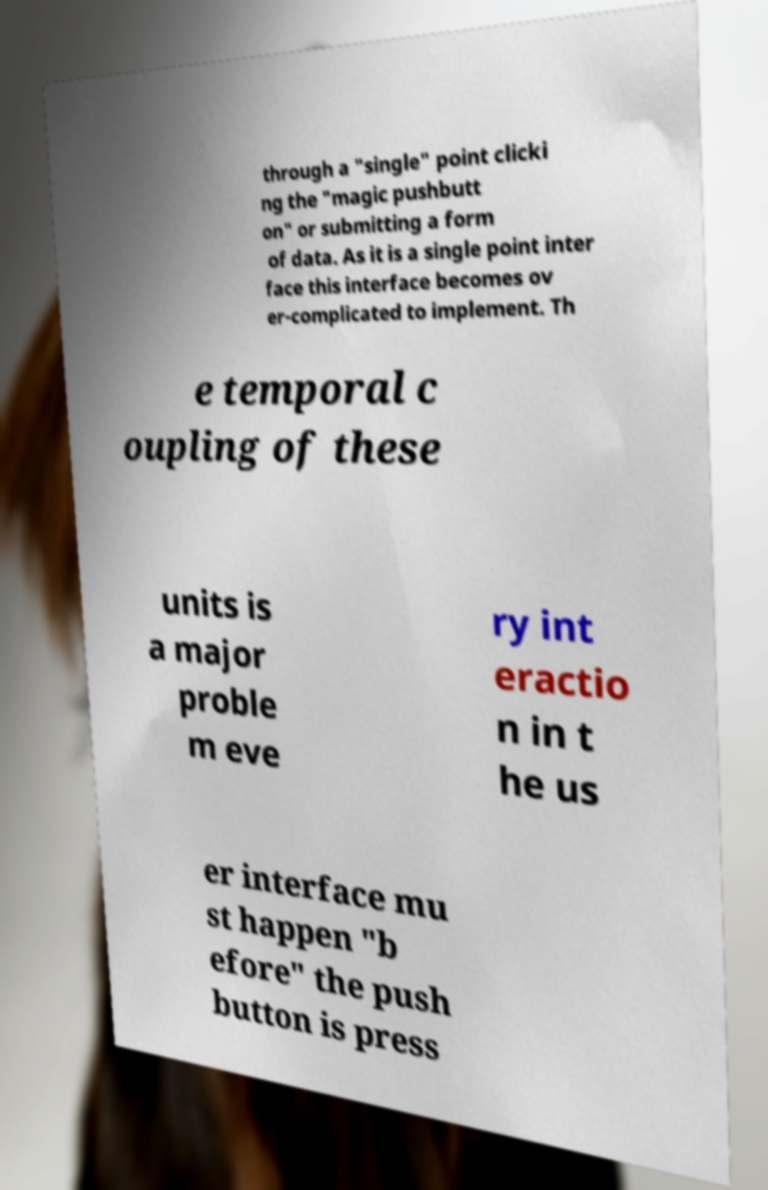Can you accurately transcribe the text from the provided image for me? through a "single" point clicki ng the "magic pushbutt on" or submitting a form of data. As it is a single point inter face this interface becomes ov er-complicated to implement. Th e temporal c oupling of these units is a major proble m eve ry int eractio n in t he us er interface mu st happen "b efore" the push button is press 